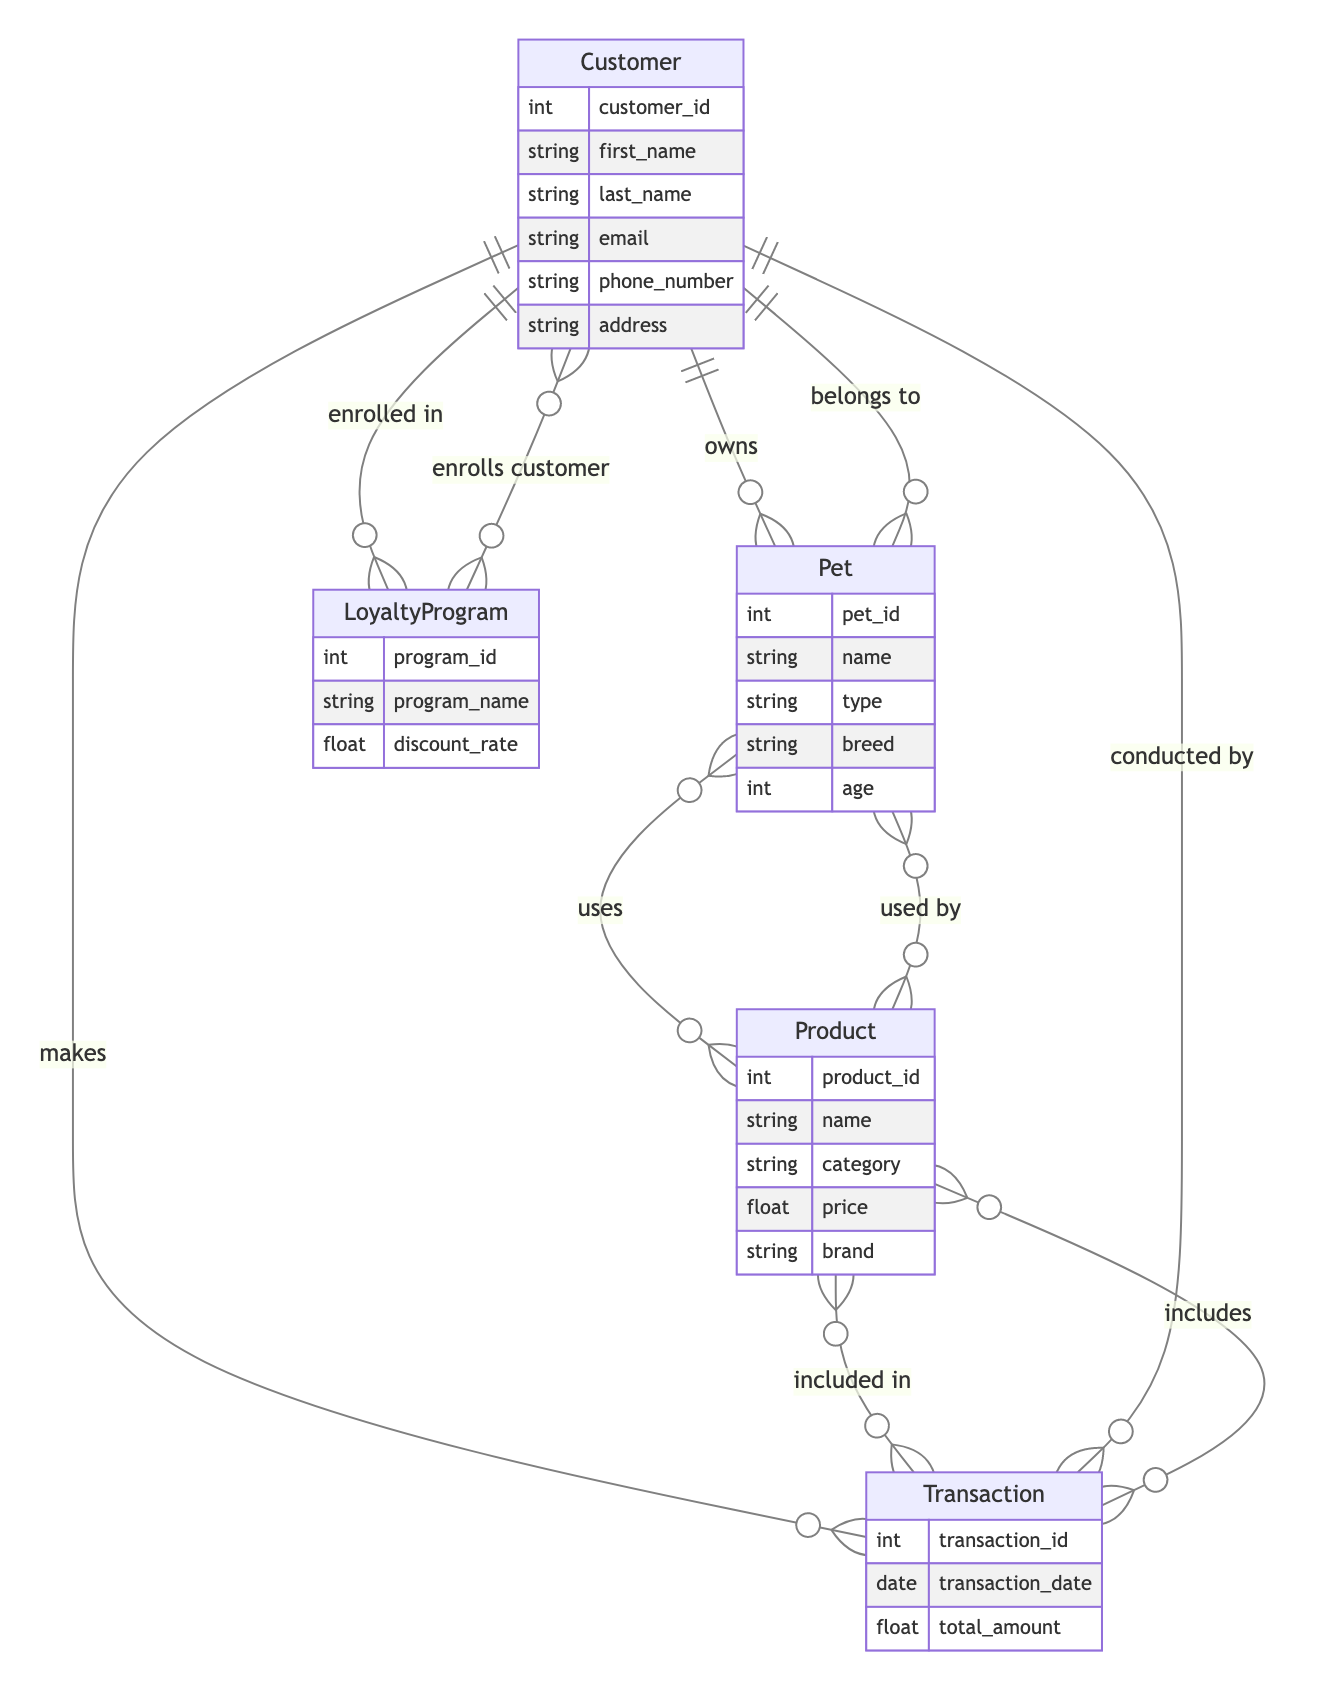What entity represents pet ownership? The entity that represents pet ownership in the diagram is "Customer," which has a relationship with the "Pet" entity defined as "owns."
Answer: Customer How many attributes does the Product entity have? The "Product" entity has five attributes: product_id, name, category, price, and brand.
Answer: 5 What is the relationship between Customer and Transaction? The relationship between "Customer" and "Transaction" is defined as "makes," meaning that customers make transactions.
Answer: makes How many entities are represented in this diagram? The diagram includes five entities: Customer, Pet, Product, Transaction, and LoyaltyProgram.
Answer: 5 Which entity is related to the LoyaltyProgram? The "Customer" entity is related to "LoyaltyProgram" through the relationship "enrolled in."
Answer: Customer What attribute of the Transaction entity indicates the amount spent? The attribute of the "Transaction" entity that indicates the amount spent is "total_amount."
Answer: total_amount What type of relationship does Pet have with Product? The relationship between "Pet" and "Product" is defined as "uses," indicating that pets use products.
Answer: uses How many different relationships does the Customer entity have? The "Customer" entity has three relationships: owns (with Pet), makes (with Transaction), and enrolled in (with LoyaltyProgram).
Answer: 3 What is the name of the entity that includes discount rates? The entity that includes discount rates is "LoyaltyProgram," which contains the attribute "discount_rate."
Answer: LoyaltyProgram 